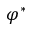Convert formula to latex. <formula><loc_0><loc_0><loc_500><loc_500>\varphi ^ { * }</formula> 